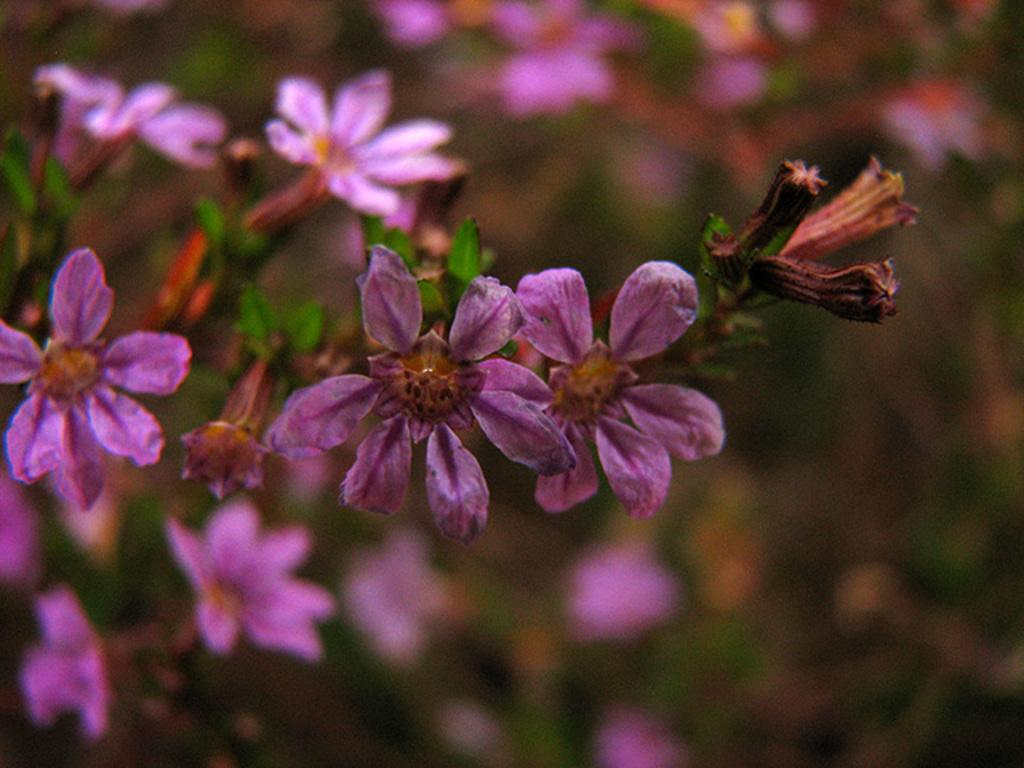What type of plant is featured in the image? There is a plant with violet colored flowers in the image. Can you describe the flowers on the plant? The flowers on the plant are violet in color. Are there any other plants visible in the image? Yes, there are other plants visible behind the violet flowered plant, but they are not clearly visible. How many eyes can be seen on the gold self in the image? There is no gold self or eyes present in the image; it features a plant with violet flowers. 